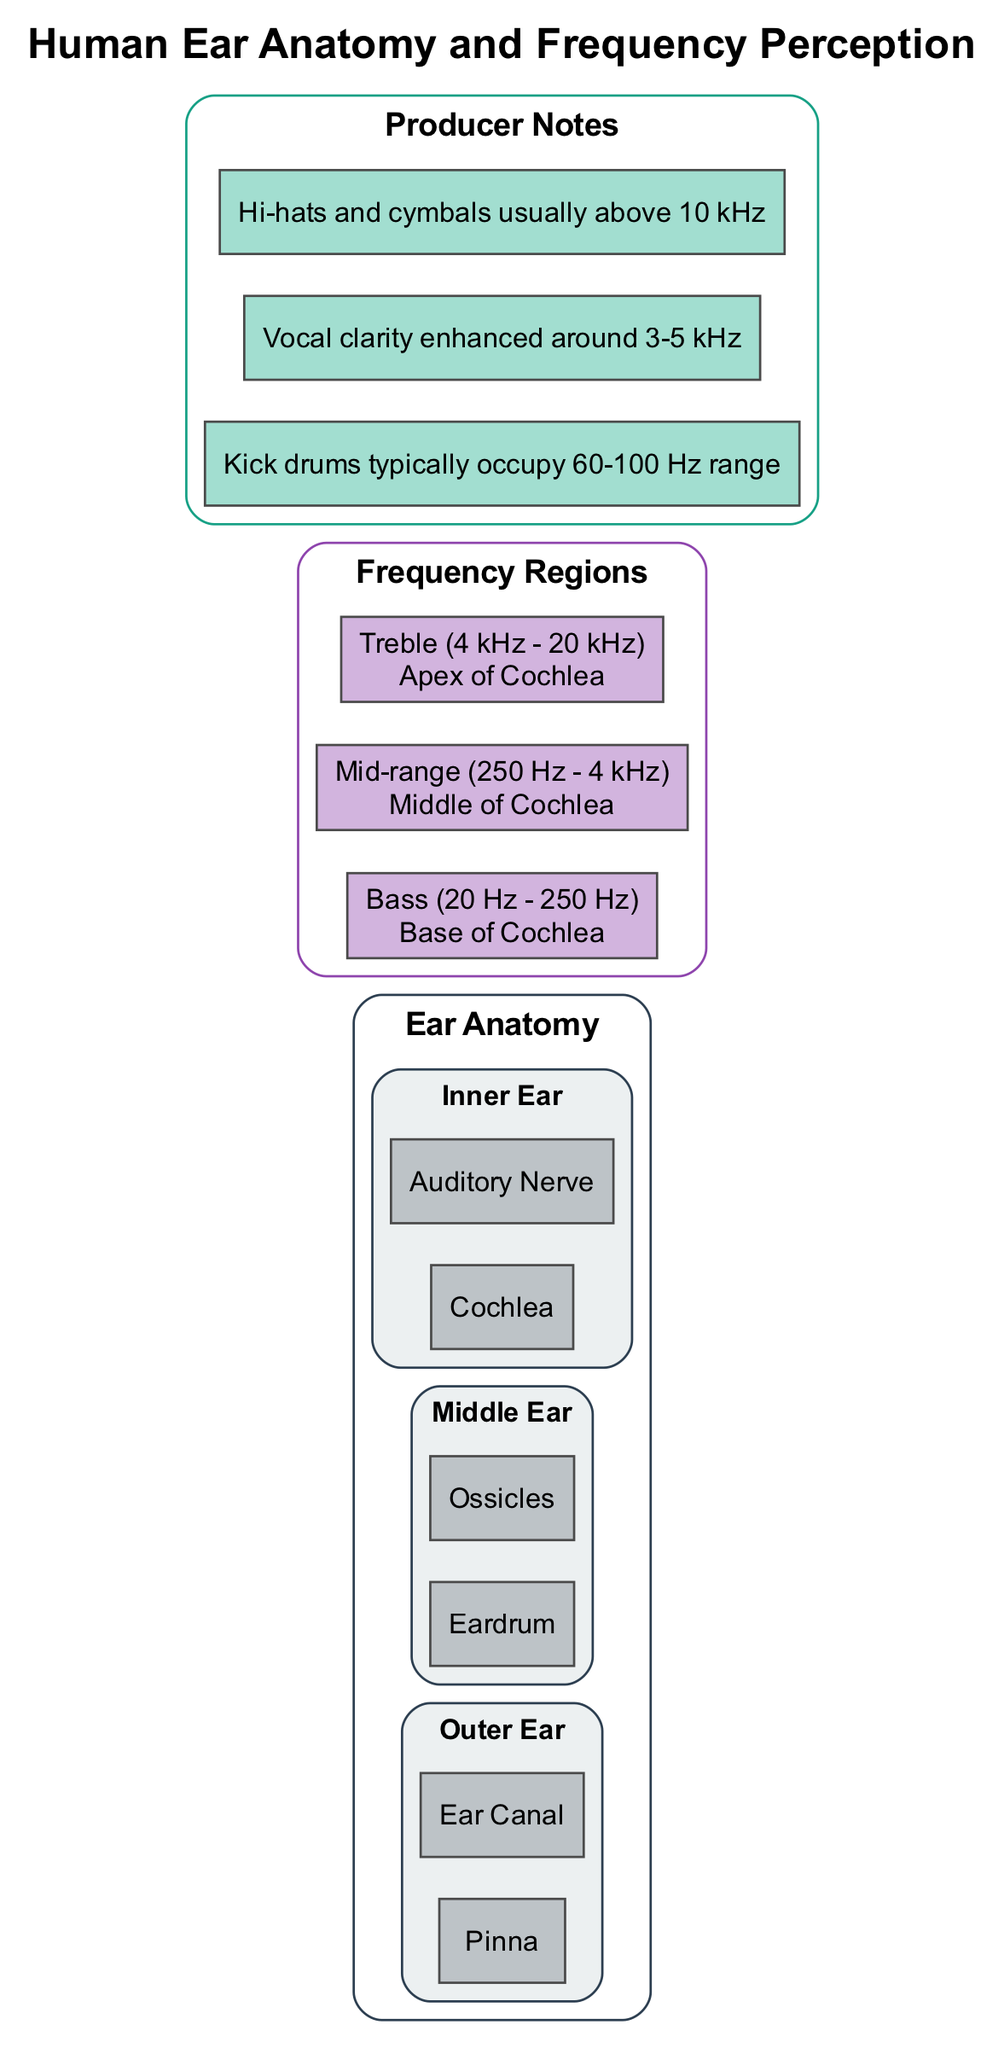What are the main parts of the human ear? The diagram lists three main parts of the ear: Outer Ear, Middle Ear, and Inner Ear. Each part contains components that contribute to hearing.
Answer: Outer Ear, Middle Ear, Inner Ear Where is the bass frequency perceived in the cochlea? The diagram indicates that bass frequencies are perceived at the base of the cochlea. This is where lower frequencies are processed.
Answer: Base of Cochlea How many components are in the Middle Ear? The Middle Ear section of the diagram shows two components listed: Eardrum and Ossicles. Therefore, there are two components.
Answer: 2 Which frequency range is enhanced for vocal clarity? According to the producer notes, vocal clarity is enhanced around the 3-5 kHz frequency range, which is typical for human voice presence in music.
Answer: 3-5 kHz Why are hi-hats and cymbals usually placed in a higher frequency range? The diagram indicates that hi-hats and cymbals are usually above 10 kHz. This placement enhances their brightness and definition in a mix.
Answer: Above 10 kHz What is the location for mid-range frequency perception? The diagram specifies that mid-range frequencies are perceived in the middle of the cochlea, where important sounds like vocals and instruments reside.
Answer: Middle of Cochlea What component of the Outer Ear is responsible for capturing sound? The Pinna, which is part of the Outer Ear, is responsible for capturing sound waves and directing them into the ear canal.
Answer: Pinna Which component transmits vibrations from the eardrum to the cochlea? The ossicles are the three small bones in the Middle Ear that transmit vibrations from the eardrum to the cochlea for further processing.
Answer: Ossicles 